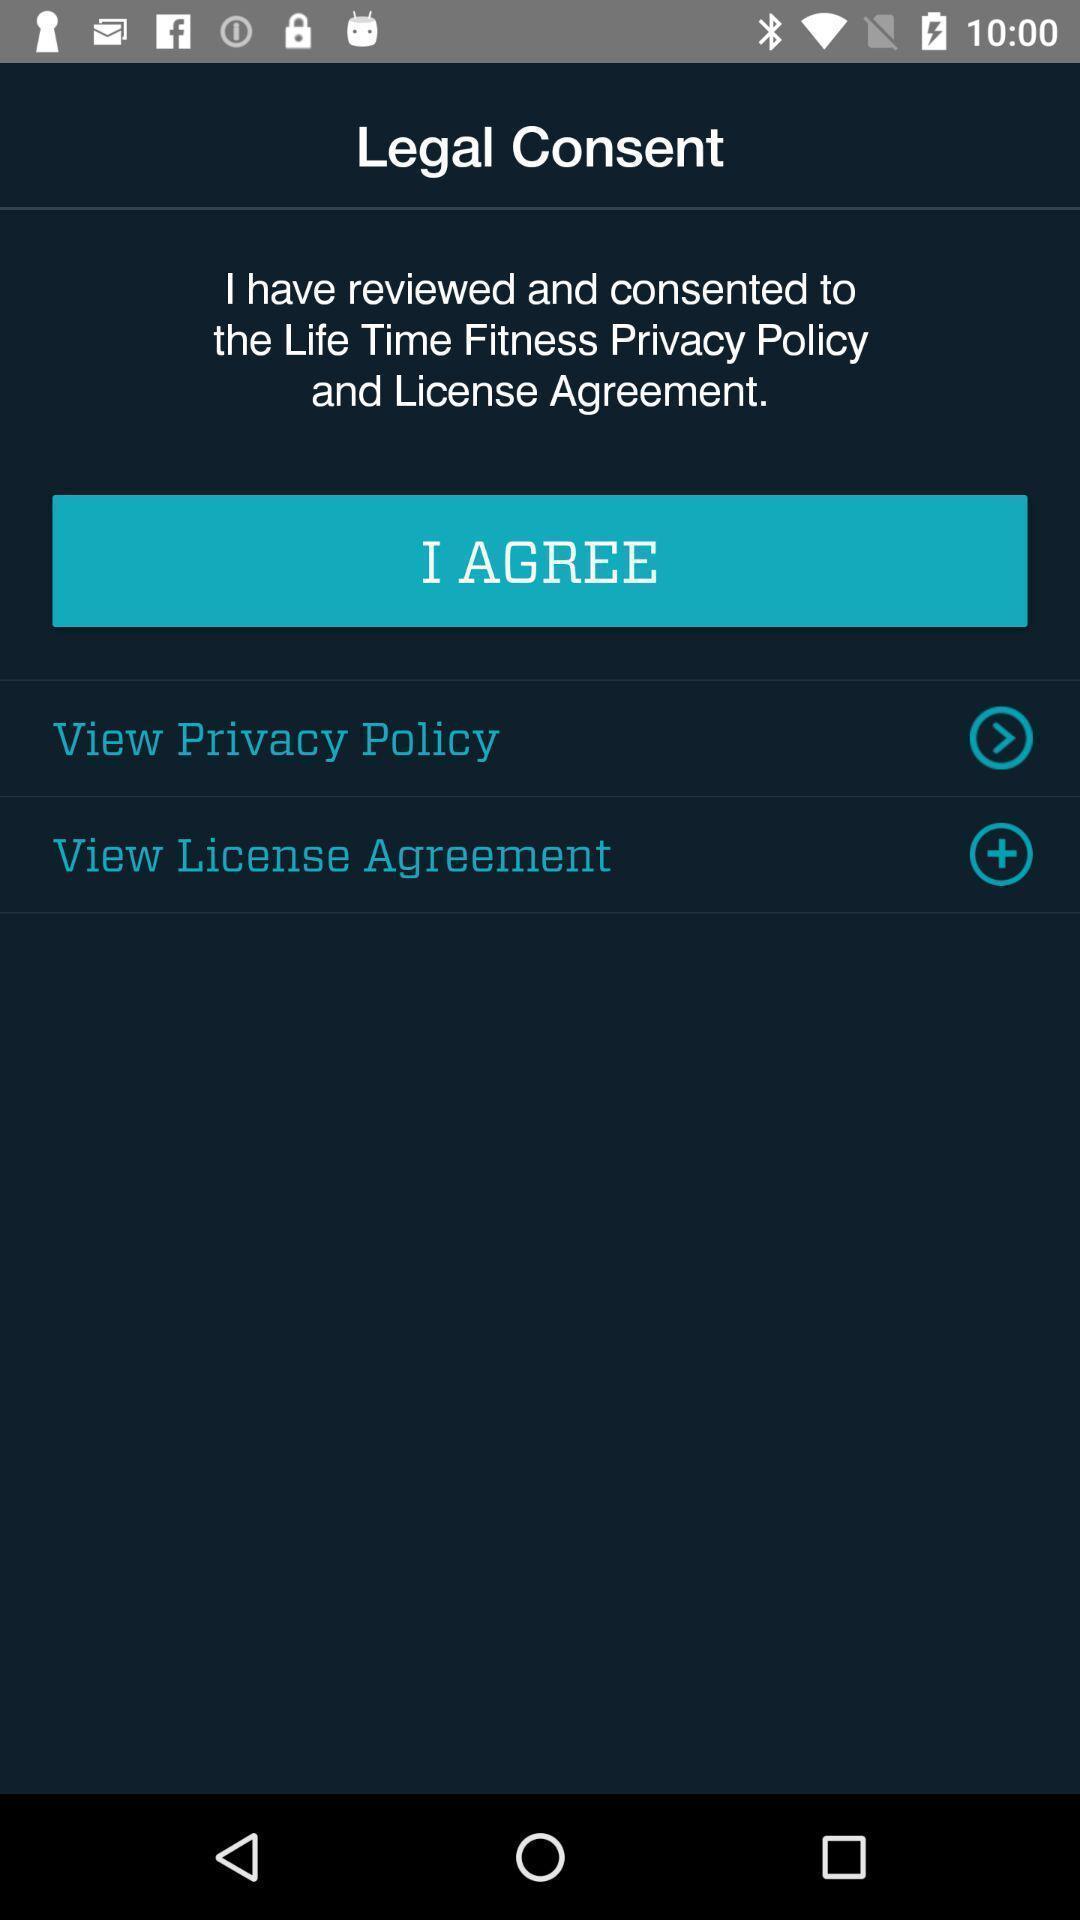Tell me about the visual elements in this screen capture. Screen displaying legal consent. 